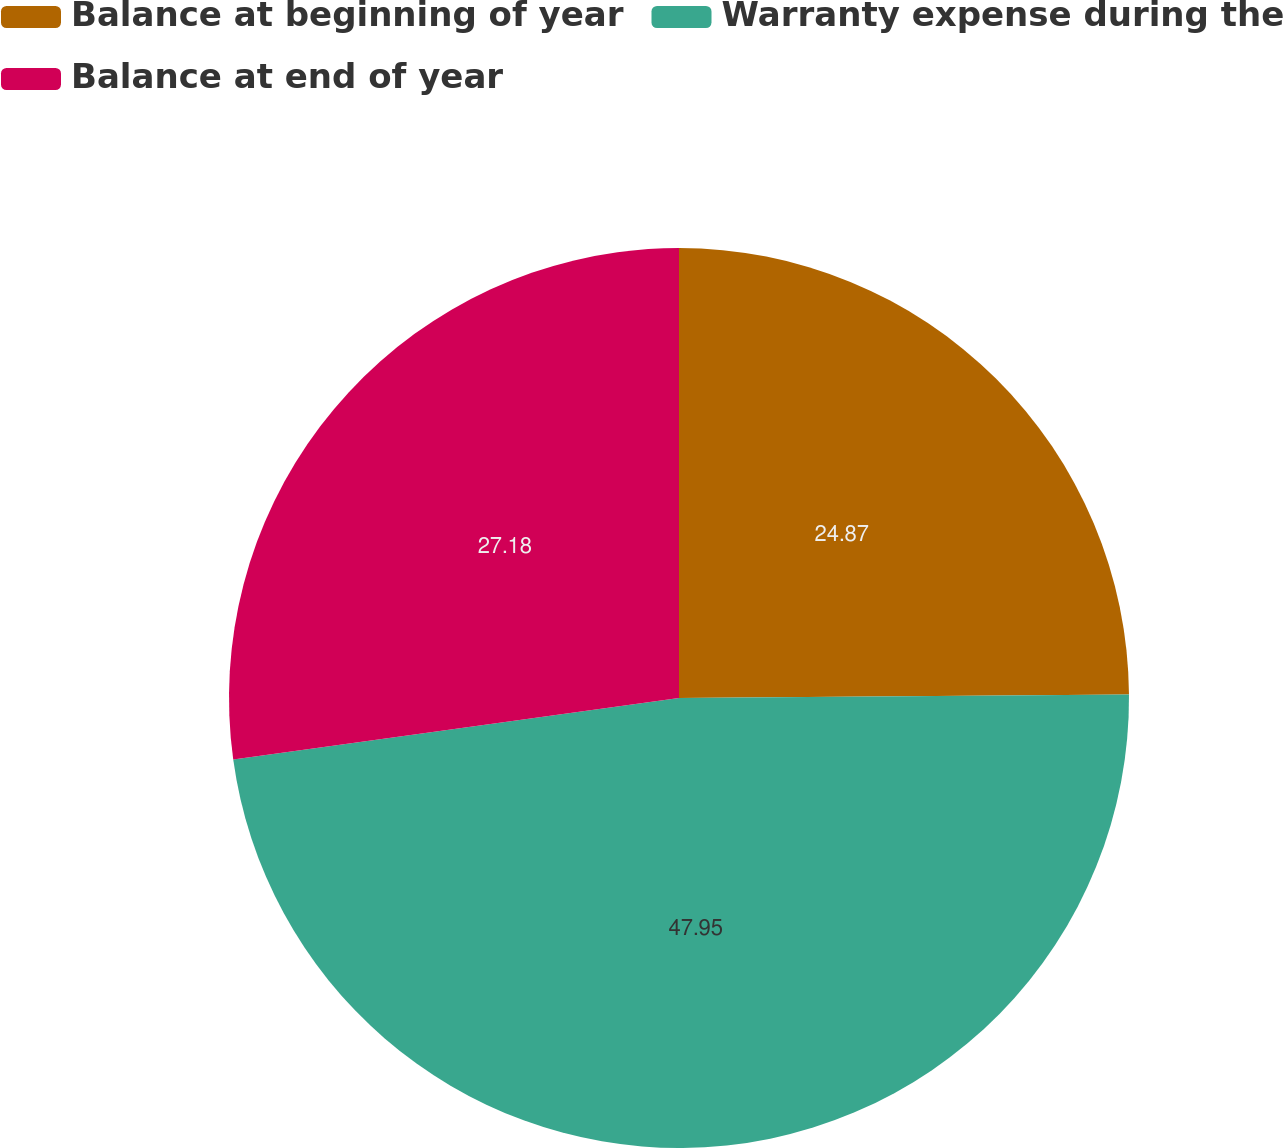<chart> <loc_0><loc_0><loc_500><loc_500><pie_chart><fcel>Balance at beginning of year<fcel>Warranty expense during the<fcel>Balance at end of year<nl><fcel>24.87%<fcel>47.94%<fcel>27.18%<nl></chart> 